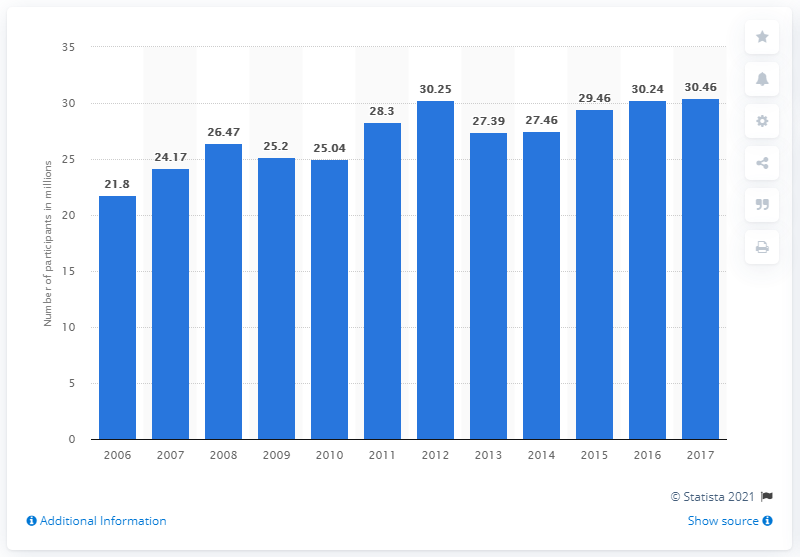Mention a couple of crucial points in this snapshot. In 2017, there were a total of 30.46 participants in target shooting. 